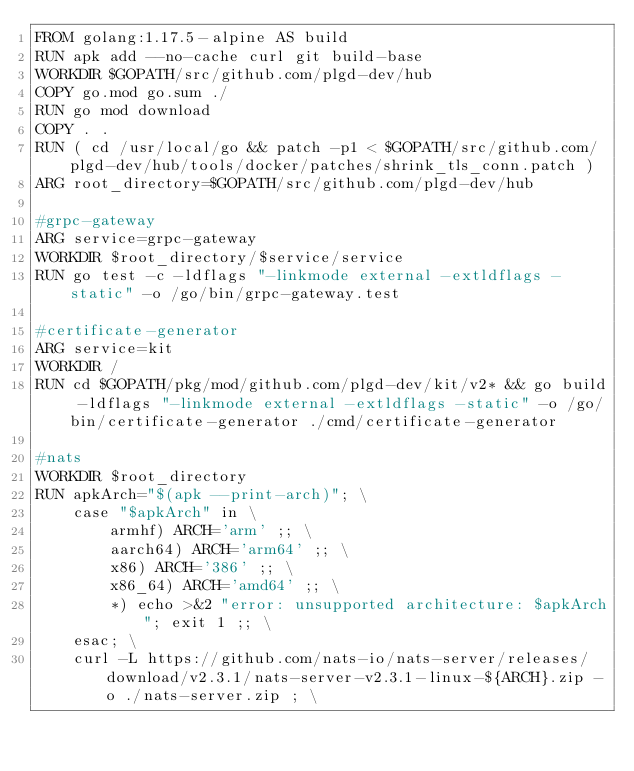<code> <loc_0><loc_0><loc_500><loc_500><_Dockerfile_>FROM golang:1.17.5-alpine AS build
RUN apk add --no-cache curl git build-base
WORKDIR $GOPATH/src/github.com/plgd-dev/hub
COPY go.mod go.sum ./
RUN go mod download
COPY . .
RUN ( cd /usr/local/go && patch -p1 < $GOPATH/src/github.com/plgd-dev/hub/tools/docker/patches/shrink_tls_conn.patch )
ARG root_directory=$GOPATH/src/github.com/plgd-dev/hub

#grpc-gateway
ARG service=grpc-gateway
WORKDIR $root_directory/$service/service
RUN go test -c -ldflags "-linkmode external -extldflags -static" -o /go/bin/grpc-gateway.test

#certificate-generator
ARG service=kit
WORKDIR /
RUN cd $GOPATH/pkg/mod/github.com/plgd-dev/kit/v2* && go build -ldflags "-linkmode external -extldflags -static" -o /go/bin/certificate-generator ./cmd/certificate-generator

#nats
WORKDIR $root_directory
RUN apkArch="$(apk --print-arch)"; \
    case "$apkArch" in \
        armhf) ARCH='arm' ;; \
        aarch64) ARCH='arm64' ;; \
        x86) ARCH='386' ;; \
        x86_64) ARCH='amd64' ;; \
        *) echo >&2 "error: unsupported architecture: $apkArch"; exit 1 ;; \
    esac; \
    curl -L https://github.com/nats-io/nats-server/releases/download/v2.3.1/nats-server-v2.3.1-linux-${ARCH}.zip -o ./nats-server.zip ; \</code> 